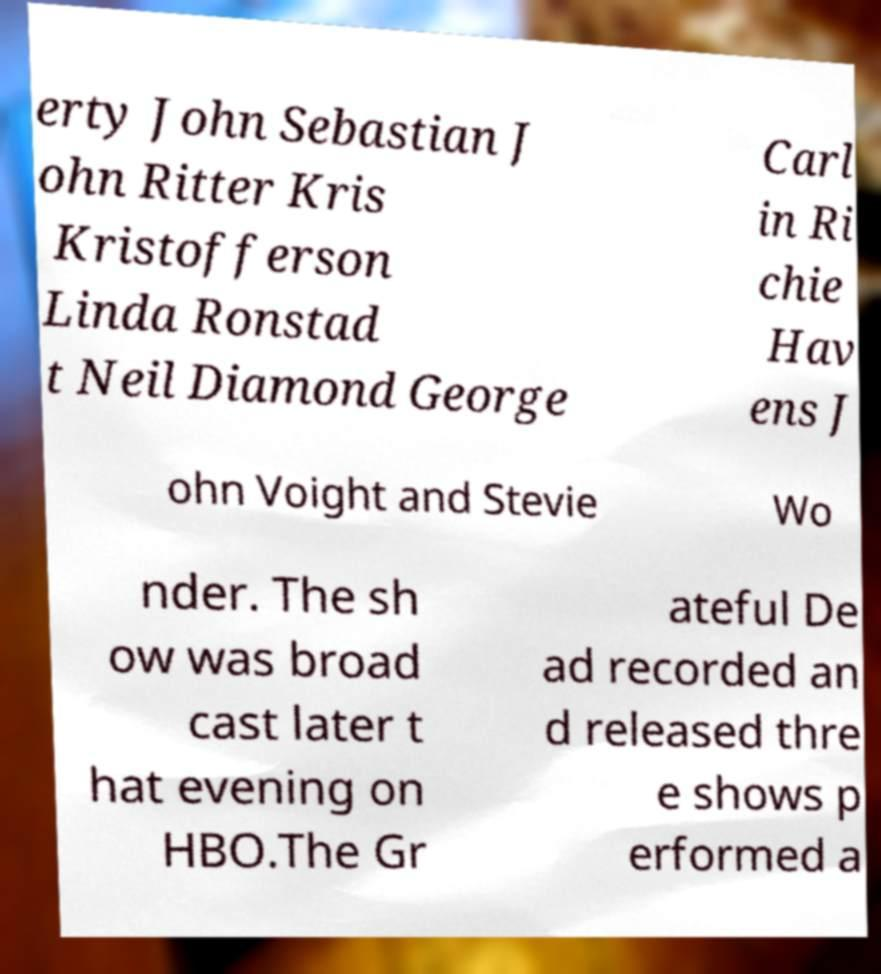Please read and relay the text visible in this image. What does it say? erty John Sebastian J ohn Ritter Kris Kristofferson Linda Ronstad t Neil Diamond George Carl in Ri chie Hav ens J ohn Voight and Stevie Wo nder. The sh ow was broad cast later t hat evening on HBO.The Gr ateful De ad recorded an d released thre e shows p erformed a 